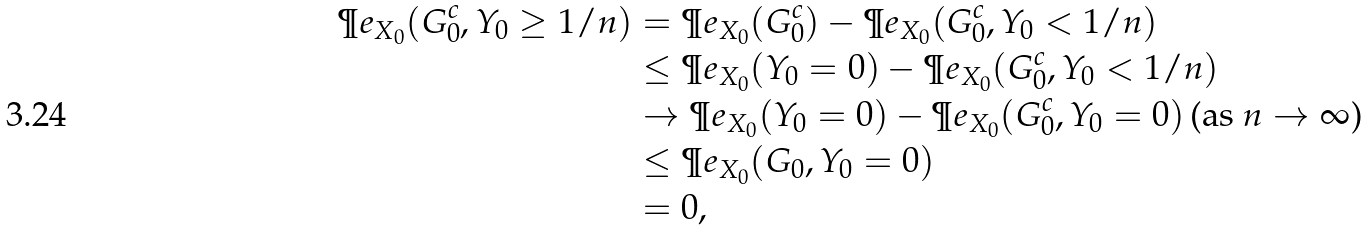<formula> <loc_0><loc_0><loc_500><loc_500>\P e _ { X _ { 0 } } ( G _ { 0 } ^ { c } , Y _ { 0 } \geq 1 / n ) & = \P e _ { X _ { 0 } } ( G _ { 0 } ^ { c } ) - \P e _ { X _ { 0 } } ( G _ { 0 } ^ { c } , Y _ { 0 } < 1 / n ) \\ & \leq \P e _ { X _ { 0 } } ( Y _ { 0 } = 0 ) - \P e _ { X _ { 0 } } ( G _ { 0 } ^ { c } , Y _ { 0 } < 1 / n ) \\ & \rightarrow \P e _ { X _ { 0 } } ( Y _ { 0 } = 0 ) - \P e _ { X _ { 0 } } ( G _ { 0 } ^ { c } , Y _ { 0 } = 0 ) \, \text {(as $n\rightarrow\infty$)} \\ & \leq \P e _ { X _ { 0 } } ( G _ { 0 } , Y _ { 0 } = 0 ) \\ & = 0 ,</formula> 